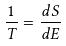Convert formula to latex. <formula><loc_0><loc_0><loc_500><loc_500>\frac { 1 } { T } = \frac { d S } { d E }</formula> 